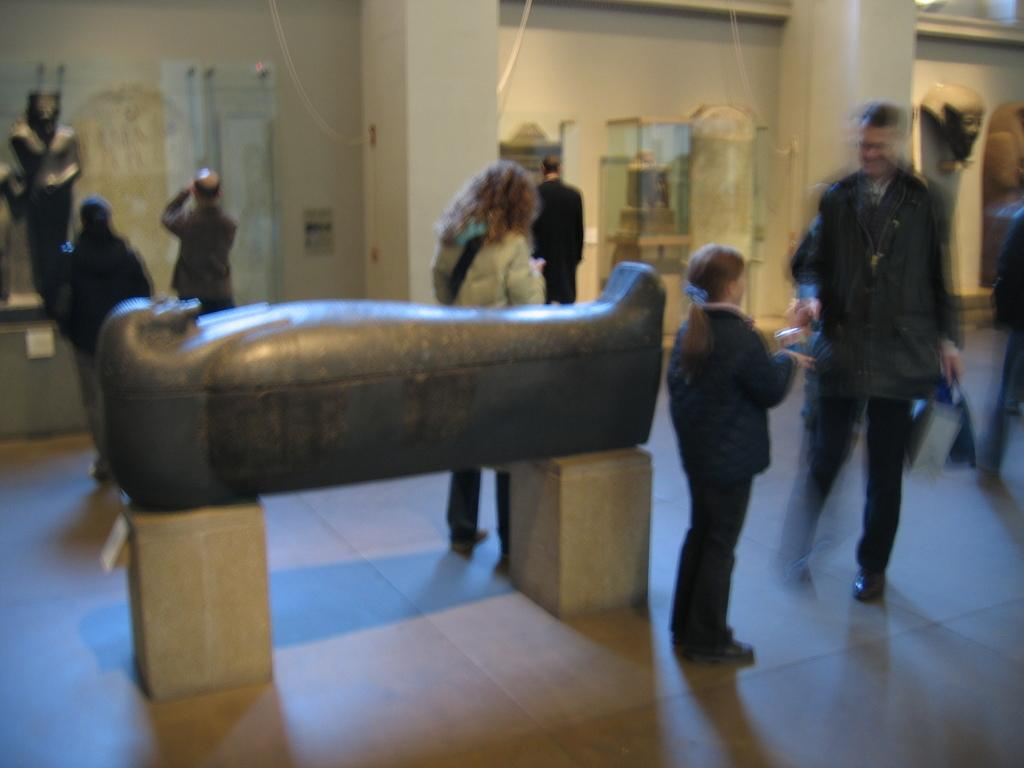What can be seen in the image? There are people standing in the image. Where are the people standing? The people are standing on the floor. What can be seen in the background of the image? There are statues, a wall, and other objects visible in the background of the image. How many boys are sitting on the cushion in the image? There is no cushion or boys present in the image. 